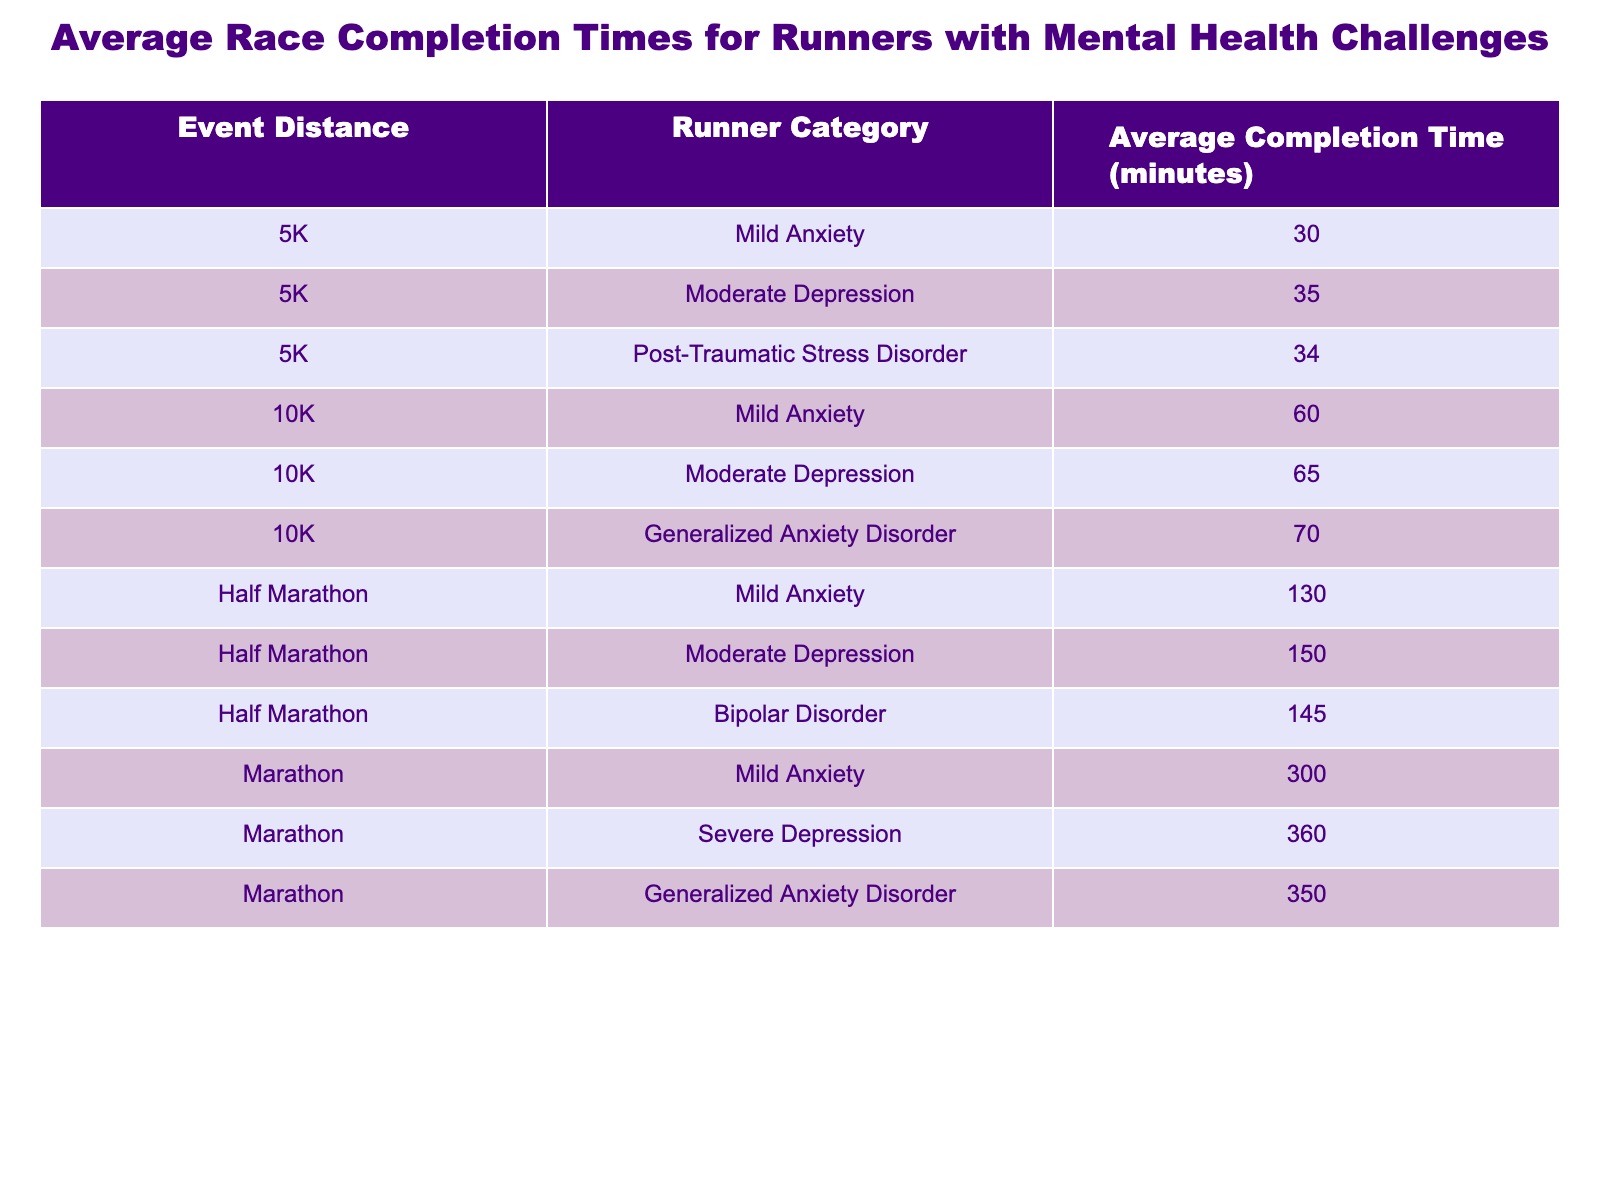What is the average completion time for the 5K event in the Mild Anxiety category? The table shows the average completion time for the 5K event under Mild Anxiety is 30 minutes.
Answer: 30 minutes What is the average completion time for the Half Marathon event for runners with Bipolar Disorder? According to the table, the average completion time for the Half Marathon for runners with Bipolar Disorder is 145 minutes.
Answer: 145 minutes Which event has the highest average completion time? The Marathon event has the highest completion time with an average of 360 minutes for Severe Depression.
Answer: Marathon What is the difference in average completion time between the Marathon and the Half Marathon for Moderate Depression? For Moderate Depression, the Marathon average is 360 minutes and the Half Marathon is 150 minutes. The difference is 360 - 150 = 210 minutes.
Answer: 210 minutes Is the average completion time for the 10K event higher for Generalized Anxiety Disorder than for Moderate Depression? For the 10K event, the average time for Generalized Anxiety Disorder is 70 minutes and for Moderate Depression, it is 65 minutes. Since 70 > 65, the statement is true.
Answer: Yes What is the average completion time for the 10K and Half Marathon events considering runners with Mild Anxiety and Moderate Depression? The average for Mild Anxiety in the 10K is 60 minutes, and for Moderate Depression, it is 65 minutes. For Half Marathon, it is 130 minutes for Mild Anxiety and 150 minutes for Moderate Depression. The average of all these times is (60 + 65 + 130 + 150) / 4 = 102.5 minutes.
Answer: 102.5 minutes Which runner category has the longest average completion time for the 5K event? In the table, the longest average for the 5K event is 35 minutes for the Moderate Depression category.
Answer: Moderate Depression How does the average completion time for Mild Anxiety in the Marathon event compare to the average for Post-Traumatic Stress Disorder in the 5K event? The average for Mild Anxiety in the Marathon is 300 minutes, while for Post-Traumatic Stress Disorder in the 5K it is 34 minutes. Therefore, 300 is greater than 34, indicating Mild Anxiety has a longer time.
Answer: Longer How many categories of mental health challenges are represented for the Half Marathon event? The Half Marathon event is represented by three categories: Mild Anxiety, Moderate Depression, and Bipolar Disorder.
Answer: Three categories What is the relationship between event distance and average completion times based on the table? As the event distance increases from 5K to Marathon, the average completion times tend to increase. For example, the 5K time is the lowest at 30 minutes, while the Marathon time goes up to 360 minutes.
Answer: Increasing average times with distance 